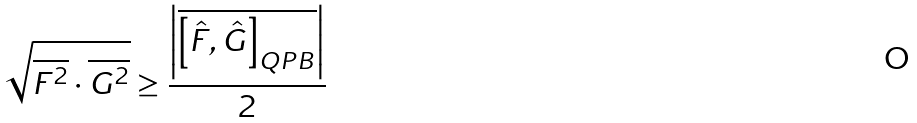<formula> <loc_0><loc_0><loc_500><loc_500>\sqrt { \overline { { { F } ^ { 2 } } } \cdot \overline { { { G } ^ { 2 } } } } \geq \frac { \left | \overline { \left [ \hat { F } , \hat { G } \right ] _ { Q P B } } \right | } { 2 }</formula> 